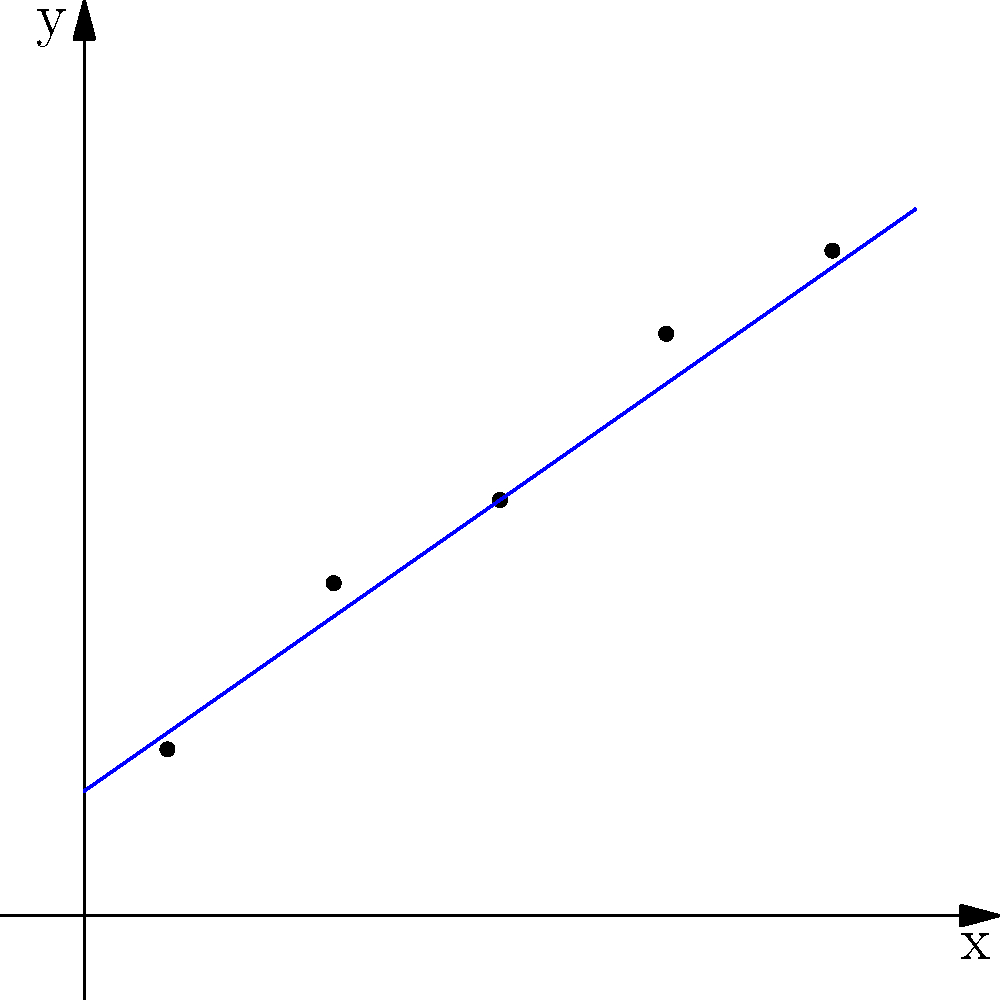Based on the scatter plot above, which of the following best describes the correlation coefficient between x and y?

A) Approximately -0.9
B) Approximately 0.5
C) Approximately 0.9
D) Approximately 0 To determine the correlation coefficient from a scatter plot, we need to analyze the following aspects:

1. Direction of the relationship:
   The points show a clear upward trend from left to right, indicating a positive correlation.

2. Strength of the relationship:
   The points are closely clustered around an imaginary straight line, suggesting a strong correlation.

3. Linearity:
   The relationship appears to be linear, as the points follow a straight-line pattern.

4. Spread of the points:
   There is minimal scatter around the trend line, indicating a high correlation.

Given these observations:

- The positive direction rules out option A (-0.9).
- The strong relationship rules out option B (0.5), which would indicate a moderate correlation.
- Option D (0) is incorrect as there is a clear relationship between x and y.

Therefore, the correlation coefficient is likely to be close to 0.9, indicating a strong positive correlation.

The blue line in the plot represents the line of best fit, which further supports this conclusion as it closely follows the data points.
Answer: C) Approximately 0.9 